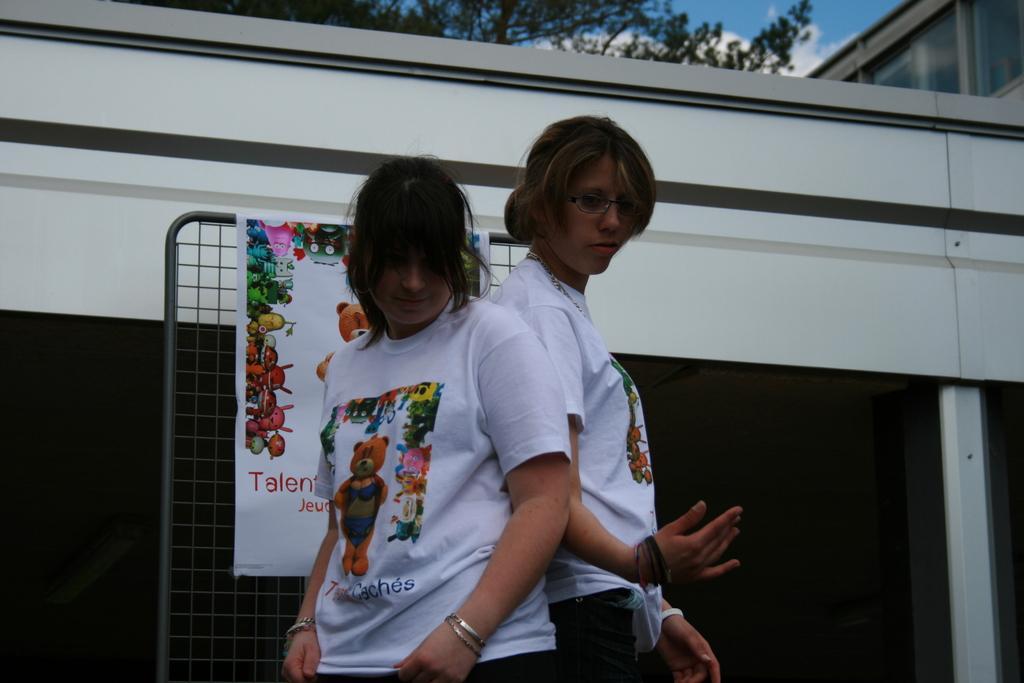Could you give a brief overview of what you see in this image? In this image I can see two women wearing a white color t-shirt standing in front of the house ,at the top I can see trees and the sky and back side of persons I can see a fence and a notice paper attached to the fence. 